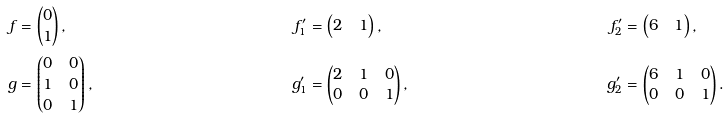Convert formula to latex. <formula><loc_0><loc_0><loc_500><loc_500>f & = \begin{pmatrix} 0 \\ 1 \end{pmatrix} , & f ^ { \prime } _ { 1 } & = \begin{pmatrix} 2 & 1 \end{pmatrix} , & f ^ { \prime } _ { 2 } & = \begin{pmatrix} 6 & 1 \end{pmatrix} , \\ g & = \begin{pmatrix} 0 & 0 \\ 1 & 0 \\ 0 & 1 \end{pmatrix} , & g ^ { \prime } _ { 1 } & = \begin{pmatrix} 2 & 1 & 0 \\ 0 & 0 & 1 \end{pmatrix} , & g ^ { \prime } _ { 2 } & = \begin{pmatrix} 6 & 1 & 0 \\ 0 & 0 & 1 \end{pmatrix} .</formula> 